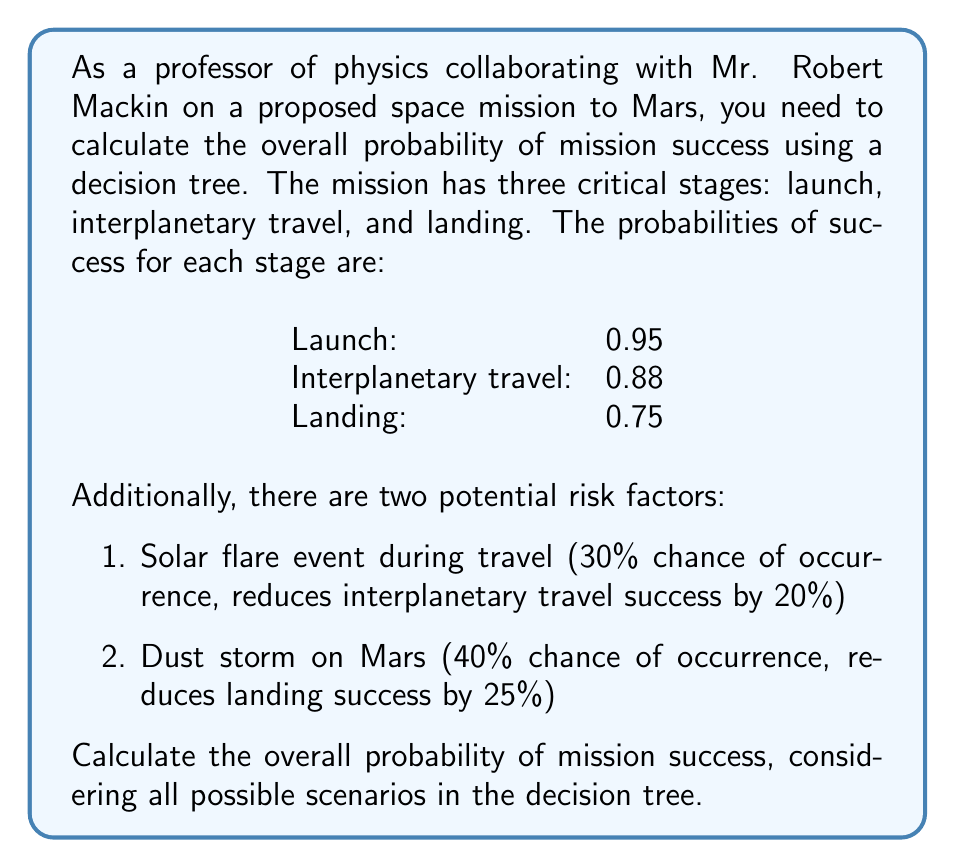Help me with this question. To solve this problem, we'll use a decision tree approach and the multiplication rule of probability. Let's break it down step by step:

1. First, let's calculate the base probabilities without considering the risk factors:

   $$P(\text{base success}) = P(\text{launch}) \times P(\text{travel}) \times P(\text{landing})$$
   $$P(\text{base success}) = 0.95 \times 0.88 \times 0.75 = 0.627$$

2. Now, let's consider the risk factors and their impact on the probabilities:

   Solar flare event (SFE):
   $$P(\text{SFE}) = 0.3$$
   $$P(\text{no SFE}) = 1 - 0.3 = 0.7$$
   
   If SFE occurs, interplanetary travel success reduces to:
   $$P(\text{travel | SFE}) = 0.88 \times (1 - 0.2) = 0.704$$

   Dust storm (DS):
   $$P(\text{DS}) = 0.4$$
   $$P(\text{no DS}) = 1 - 0.4 = 0.6$$
   
   If DS occurs, landing success reduces to:
   $$P(\text{landing | DS}) = 0.75 \times (1 - 0.25) = 0.5625$$

3. Now, we can calculate the probability of success for each scenario:

   Scenario 1 (No SFE, No DS):
   $$P_1 = 0.7 \times 0.6 \times 0.95 \times 0.88 \times 0.75 = 0.26334$$

   Scenario 2 (SFE, No DS):
   $$P_2 = 0.3 \times 0.6 \times 0.95 \times 0.704 \times 0.75 = 0.09018$$

   Scenario 3 (No SFE, DS):
   $$P_3 = 0.7 \times 0.4 \times 0.95 \times 0.88 \times 0.5625 = 0.13167$$

   Scenario 4 (SFE, DS):
   $$P_4 = 0.3 \times 0.4 \times 0.95 \times 0.704 \times 0.5625 = 0.04509$$

4. The overall probability of mission success is the sum of all scenario probabilities:

   $$P(\text{success}) = P_1 + P_2 + P_3 + P_4$$
   $$P(\text{success}) = 0.26334 + 0.09018 + 0.13167 + 0.04509 = 0.53028$$
Answer: The overall probability of mission success, considering all possible scenarios in the decision tree, is approximately 0.53028 or 53.028%. 